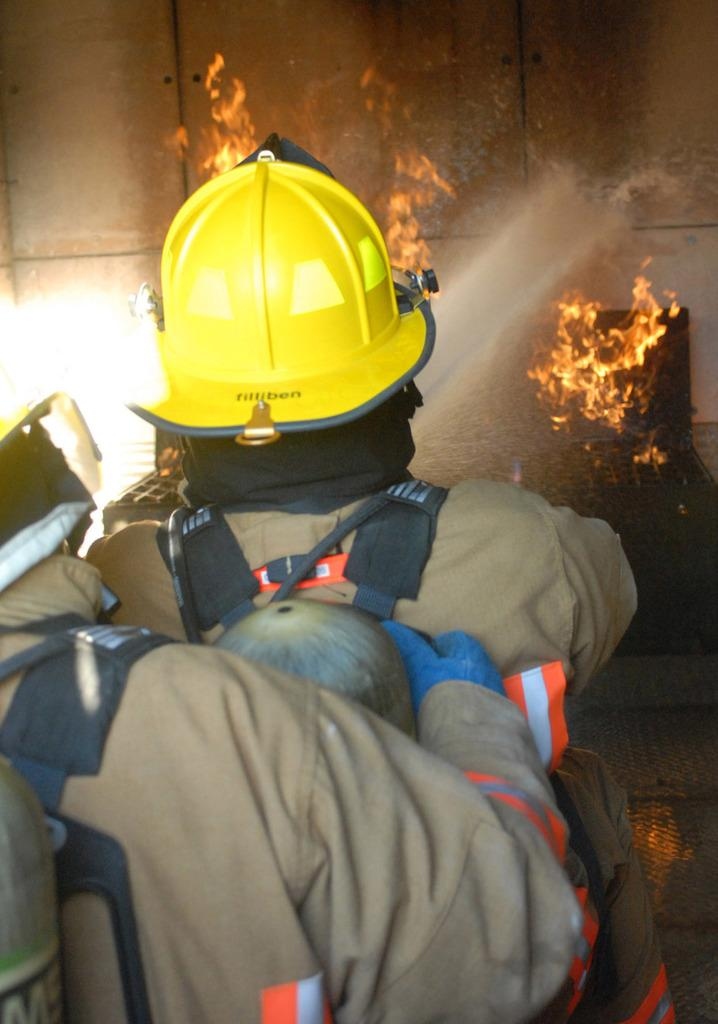How many people are in the image? There are two persons in the image. What is one person wearing? One person is wearing a helmet. What is the person with the helmet carrying? The person with the helmet is carrying a cylinder bag on his shoulders. What is the person with the helmet doing? The person with the helmet is watering on a fire. What can be seen in the background of the image? There is a wall in the image. What type of toothpaste is visible in the image? There is no toothpaste present in the image. What things can be seen in the airport depicted in the image? There is no airport depicted in the image. 